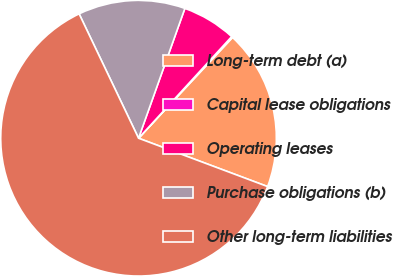Convert chart to OTSL. <chart><loc_0><loc_0><loc_500><loc_500><pie_chart><fcel>Long-term debt (a)<fcel>Capital lease obligations<fcel>Operating leases<fcel>Purchase obligations (b)<fcel>Other long-term liabilities<nl><fcel>18.76%<fcel>0.14%<fcel>6.35%<fcel>12.55%<fcel>62.2%<nl></chart> 